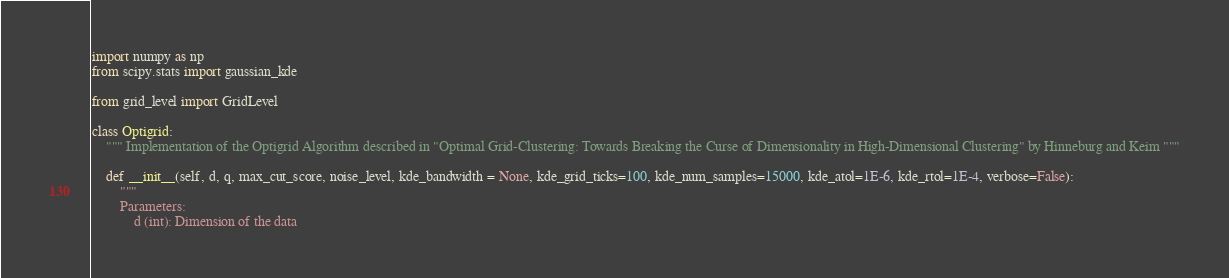Convert code to text. <code><loc_0><loc_0><loc_500><loc_500><_Python_>import numpy as np
from scipy.stats import gaussian_kde

from grid_level import GridLevel

class Optigrid:
    """ Implementation of the Optigrid Algorithm described in "Optimal Grid-Clustering: Towards Breaking the Curse of Dimensionality in High-Dimensional Clustering" by Hinneburg and Keim """

    def __init__(self, d, q, max_cut_score, noise_level, kde_bandwidth = None, kde_grid_ticks=100, kde_num_samples=15000, kde_atol=1E-6, kde_rtol=1E-4, verbose=False):
        """ 
        Parameters:
            d (int): Dimension of the data</code> 